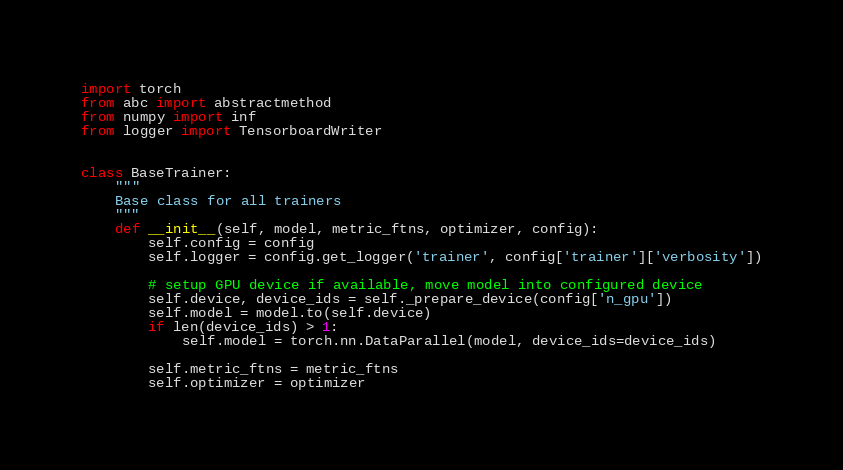Convert code to text. <code><loc_0><loc_0><loc_500><loc_500><_Python_>import torch
from abc import abstractmethod
from numpy import inf
from logger import TensorboardWriter


class BaseTrainer:
    """
    Base class for all trainers
    """
    def __init__(self, model, metric_ftns, optimizer, config):
        self.config = config
        self.logger = config.get_logger('trainer', config['trainer']['verbosity'])

        # setup GPU device if available, move model into configured device
        self.device, device_ids = self._prepare_device(config['n_gpu'])
        self.model = model.to(self.device)
        if len(device_ids) > 1:
            self.model = torch.nn.DataParallel(model, device_ids=device_ids)

        self.metric_ftns = metric_ftns
        self.optimizer = optimizer
</code> 